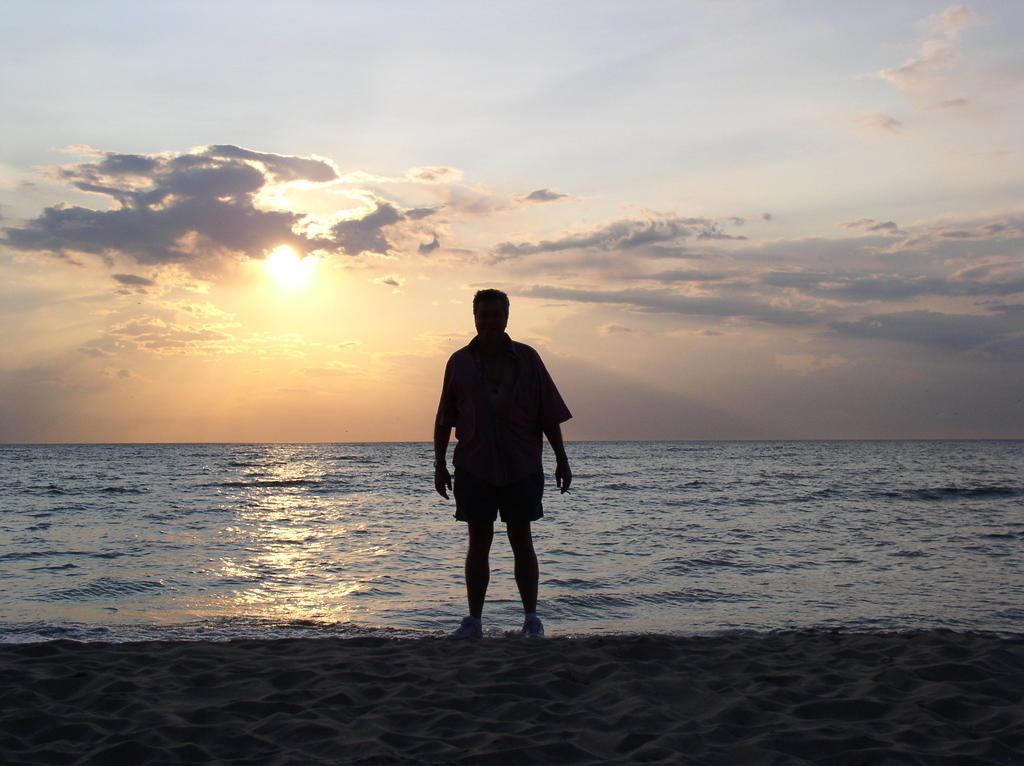What is the main subject of the image? There is a person standing in the center of the image. What type of terrain is visible at the bottom of the image? There is sand at the bottom of the image. What can be seen in the background of the image? The sky, clouds, the sun, and water are visible in the background of the image. What type of stocking is the person wearing in the image? There is no information about the person's clothing, including stockings, in the image. What type of breakfast is the person eating in the image? There is no food or breakfast visible in the image. 